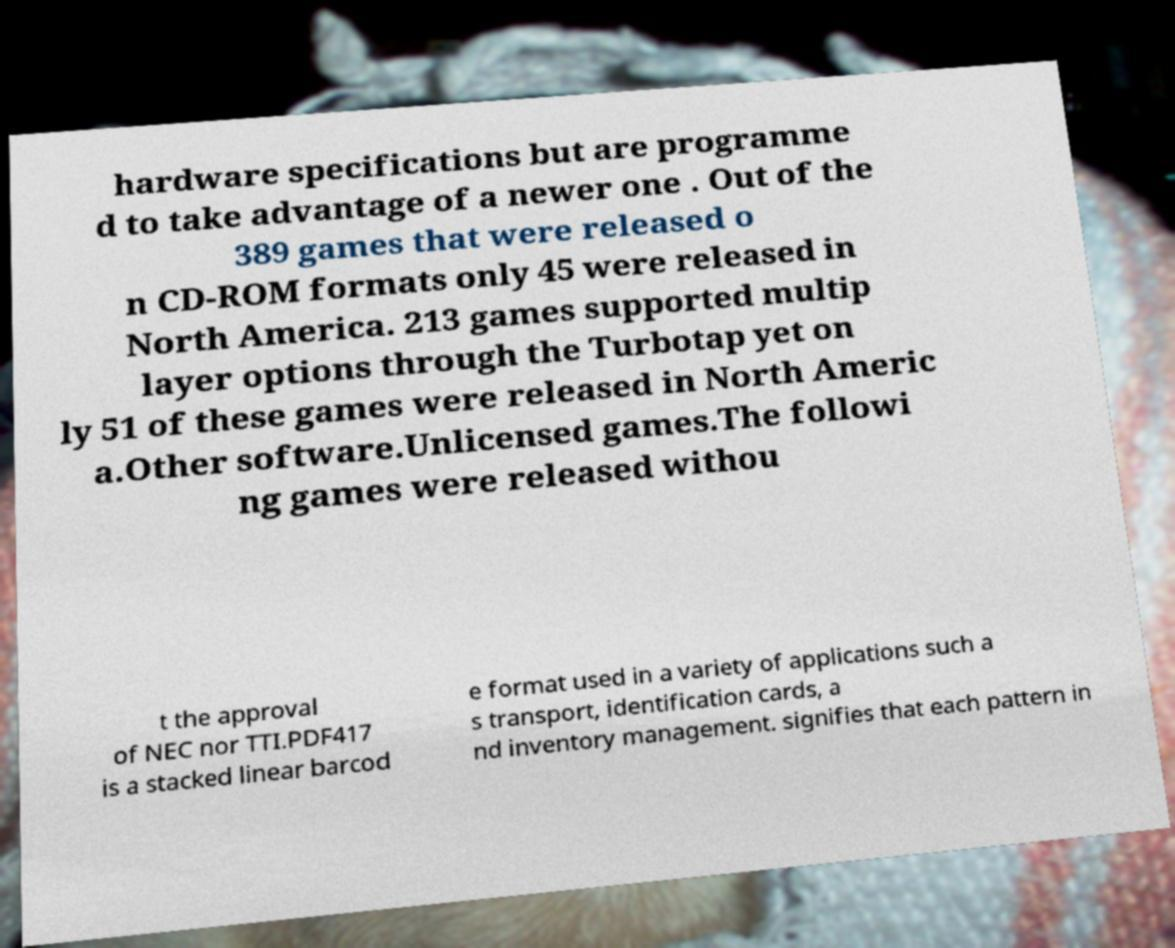Can you accurately transcribe the text from the provided image for me? hardware specifications but are programme d to take advantage of a newer one . Out of the 389 games that were released o n CD-ROM formats only 45 were released in North America. 213 games supported multip layer options through the Turbotap yet on ly 51 of these games were released in North Americ a.Other software.Unlicensed games.The followi ng games were released withou t the approval of NEC nor TTI.PDF417 is a stacked linear barcod e format used in a variety of applications such a s transport, identification cards, a nd inventory management. signifies that each pattern in 